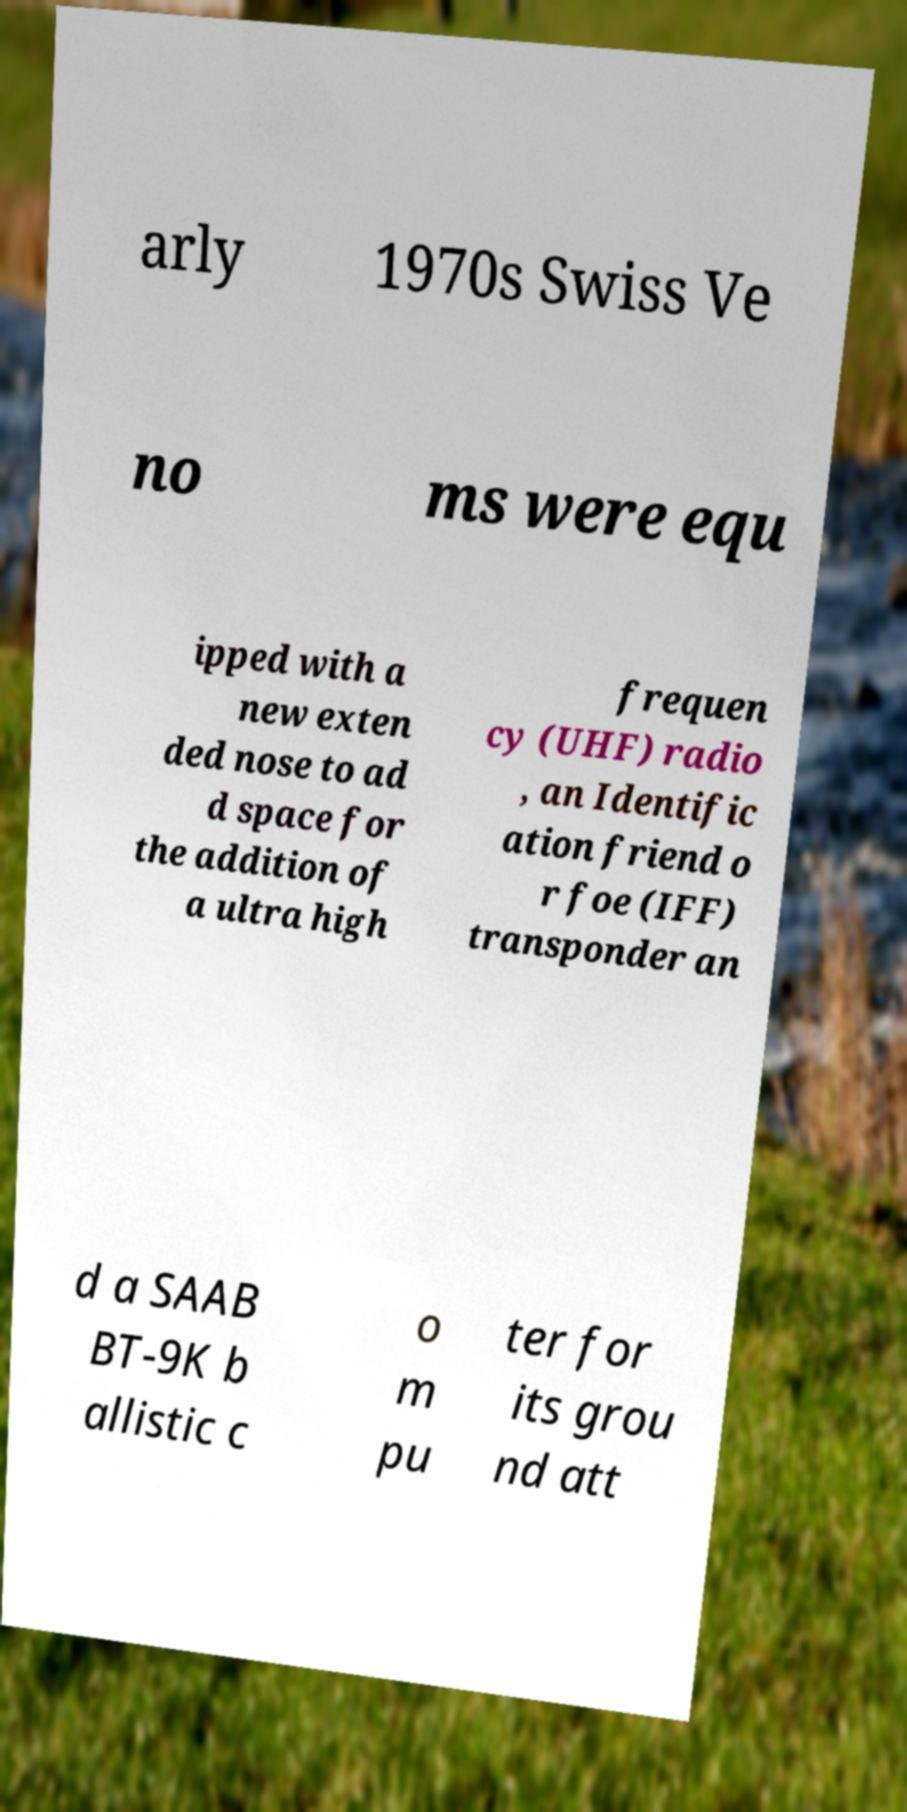For documentation purposes, I need the text within this image transcribed. Could you provide that? arly 1970s Swiss Ve no ms were equ ipped with a new exten ded nose to ad d space for the addition of a ultra high frequen cy (UHF) radio , an Identific ation friend o r foe (IFF) transponder an d a SAAB BT-9K b allistic c o m pu ter for its grou nd att 